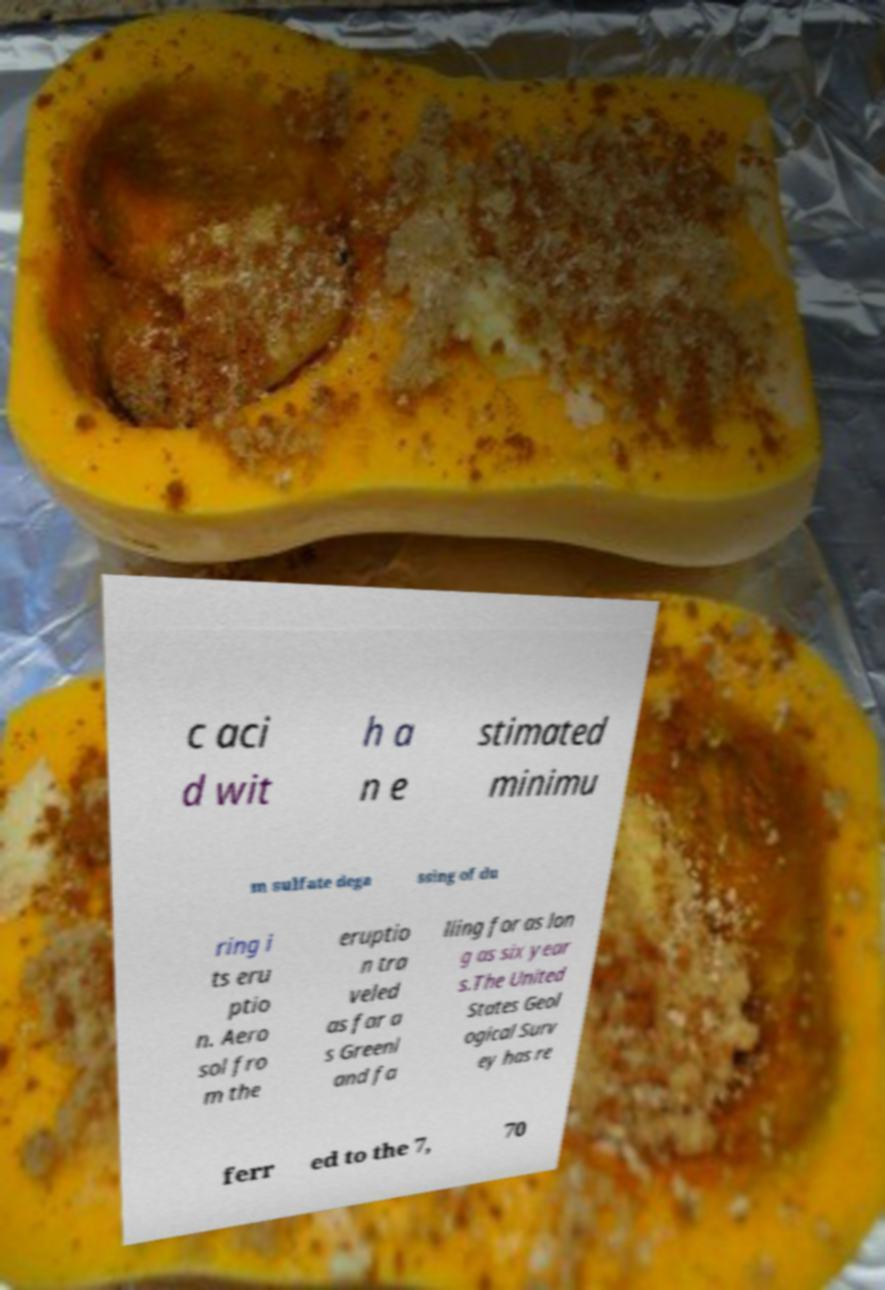What messages or text are displayed in this image? I need them in a readable, typed format. c aci d wit h a n e stimated minimu m sulfate dega ssing of du ring i ts eru ptio n. Aero sol fro m the eruptio n tra veled as far a s Greenl and fa lling for as lon g as six year s.The United States Geol ogical Surv ey has re ferr ed to the 7, 70 